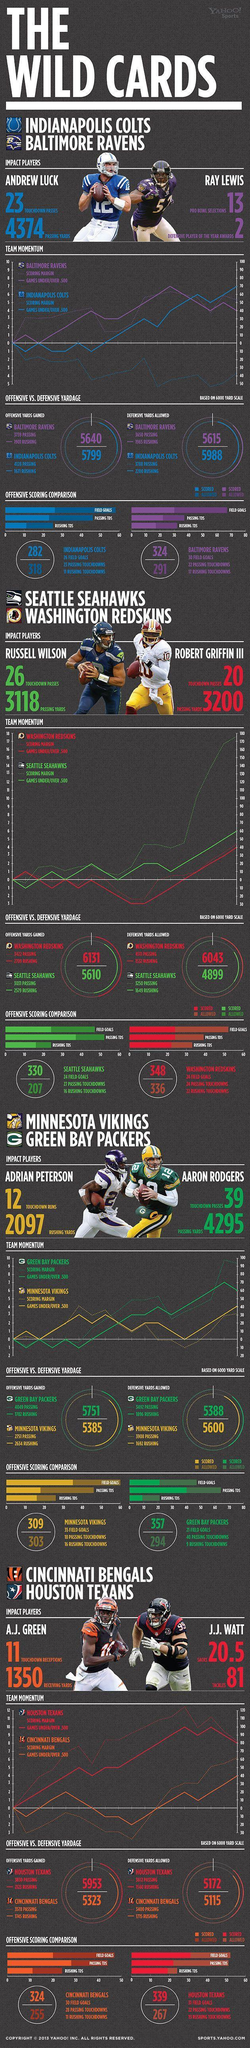How much is the Passing Yards of Robert Griffin?
Answer the question with a short phrase. 3200 How many are the Rushing Touchdowns of Baltimore Ravens? 17 How many are the Passing Touchdowns of Baltimore Ravens? 22 What is the number of Touchdown passes by Robert Griffin? 20 Robert Griffin III belongs to which team? Washington Redskins What is the field goals of Baltimore Ravens? 30 What are the Defensive yards allowed for Indianapolis Colts? 5988 Who is the wild card entry to the Baltimore Ravens? Ray Lewis What is the field goals of Indianapolis Colts? 26 What is the color-code given to Seattle SeaHawks- red, white, green, blue? green 